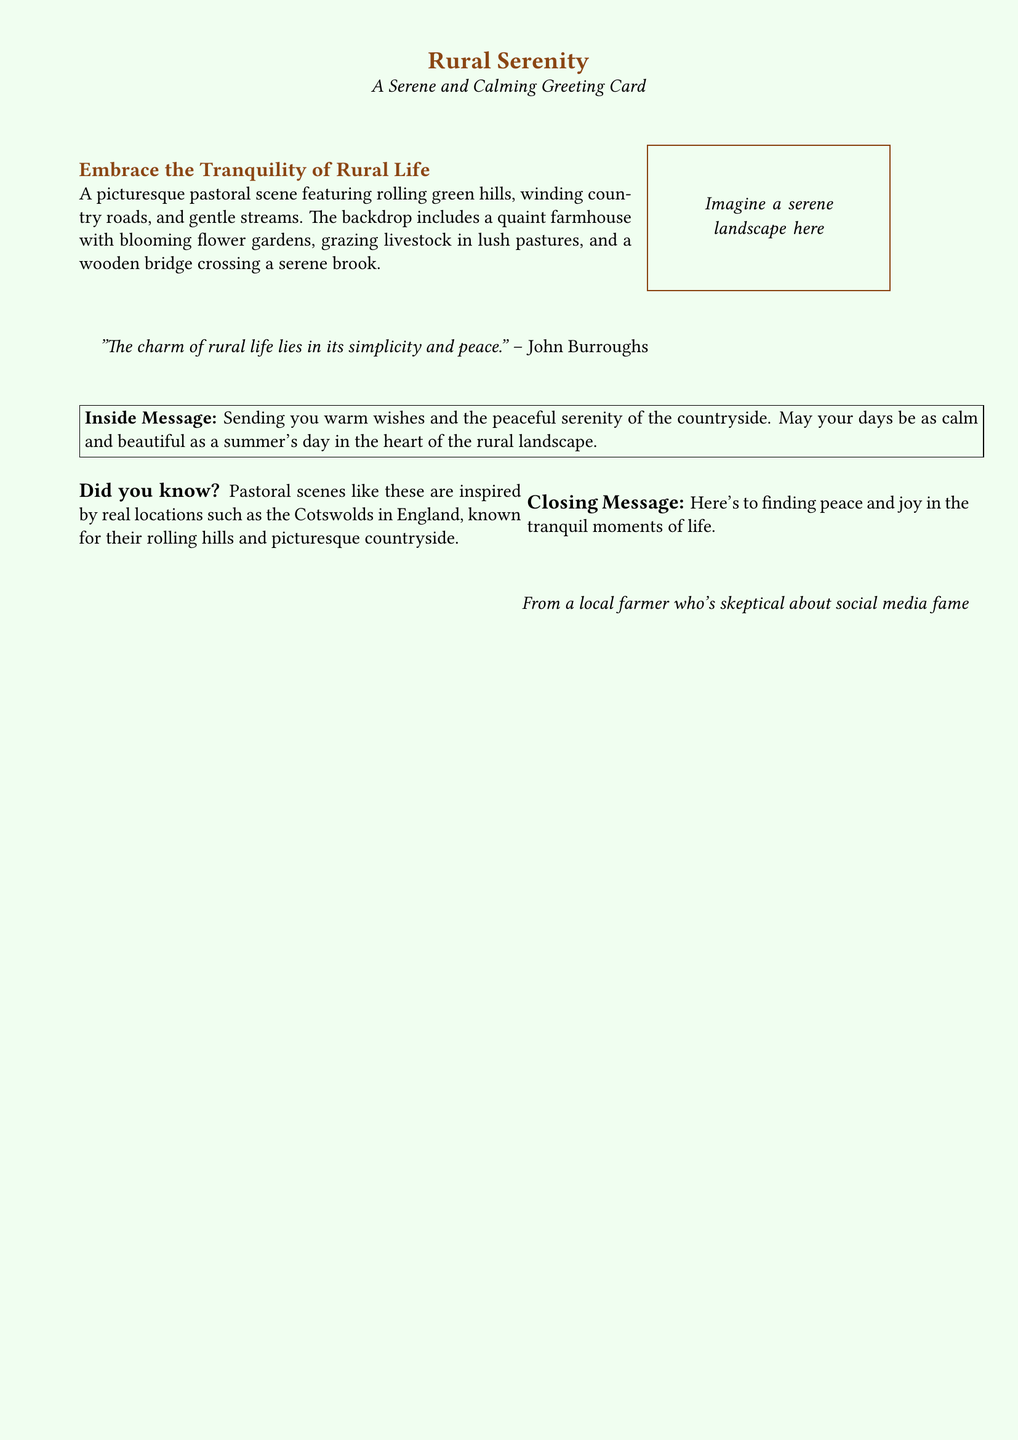What is the title of the greeting card? The title is displayed prominently at the top of the card in dark brown text.
Answer: Rural Serenity What color is the background of the greeting card? The background color is described in the document as a pastel green with a specific shade definition.
Answer: Pastel green Who is quoted in the document? The quote is attributed to a well-known naturalist, which is indicated below the pastoral scene.
Answer: John Burroughs What kind of scene is depicted in the card? The document describes the scene as one that features specific elements that relate to rural settings.
Answer: Pastoral scene What is the inside message of the greeting card? The inside message is enclosed within a box and conveys warm wishes tied to the rural environment.
Answer: Sending you warm wishes and the peaceful serenity of the countryside What is the closing message of the card? The closing message summarizes the essence of the card's theme and provides a well wish.
Answer: Here's to finding peace and joy in the tranquil moments of life What is the size of the greeting card text? The specified size of the text within the document is indicated at the top.
Answer: 12pt What type of life does the card embrace? The card's theme emphasizes a particular lifestyle that is often contrasted with urban life, indicated in the document.
Answer: Rural life What location is mentioned as an inspiration for pastoral scenes? The document provides a specific geographic location known for its countryside that serves as a reference.
Answer: Cotswolds in England 